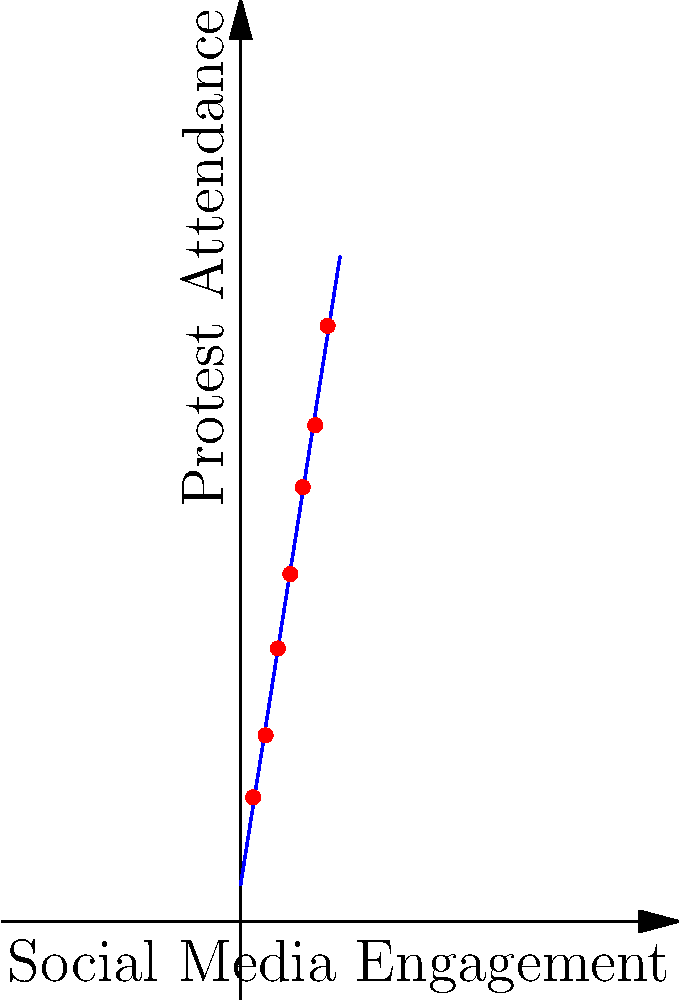Given the data points representing the correlation between protest attendance (y-axis) and social media engagement (x-axis), determine the equation of the line of best fit using the least squares method. Round coefficients to two decimal places. To find the line of best fit using the least squares method, we'll use the formula:

$y = mx + b$

Where $m$ is the slope and $b$ is the y-intercept.

Step 1: Calculate the required sums:
$\sum x = 28$
$\sum y = 198$
$\sum xy = 824$
$\sum x^2 = 140$
$n = 7$ (number of data points)

Step 2: Calculate the slope (m):
$m = \frac{n(\sum xy) - (\sum x)(\sum y)}{n(\sum x^2) - (\sum x)^2}$
$m = \frac{7(824) - (28)(198)}{7(140) - (28)^2}$
$m = \frac{5768 - 5544}{980 - 784}$
$m = \frac{224}{196} = 1.14285714$

Step 3: Calculate the y-intercept (b):
$b = \frac{\sum y - m(\sum x)}{n}$
$b = \frac{198 - 1.14285714(28)}{7}$
$b = \frac{198 - 32}{7} = 7.14285714$

Step 4: Round coefficients to two decimal places:
$m \approx 1.14$
$b \approx 7.14$

Therefore, the equation of the line of best fit is:
$y = 1.14x + 7.14$
Answer: $y = 1.14x + 7.14$ 